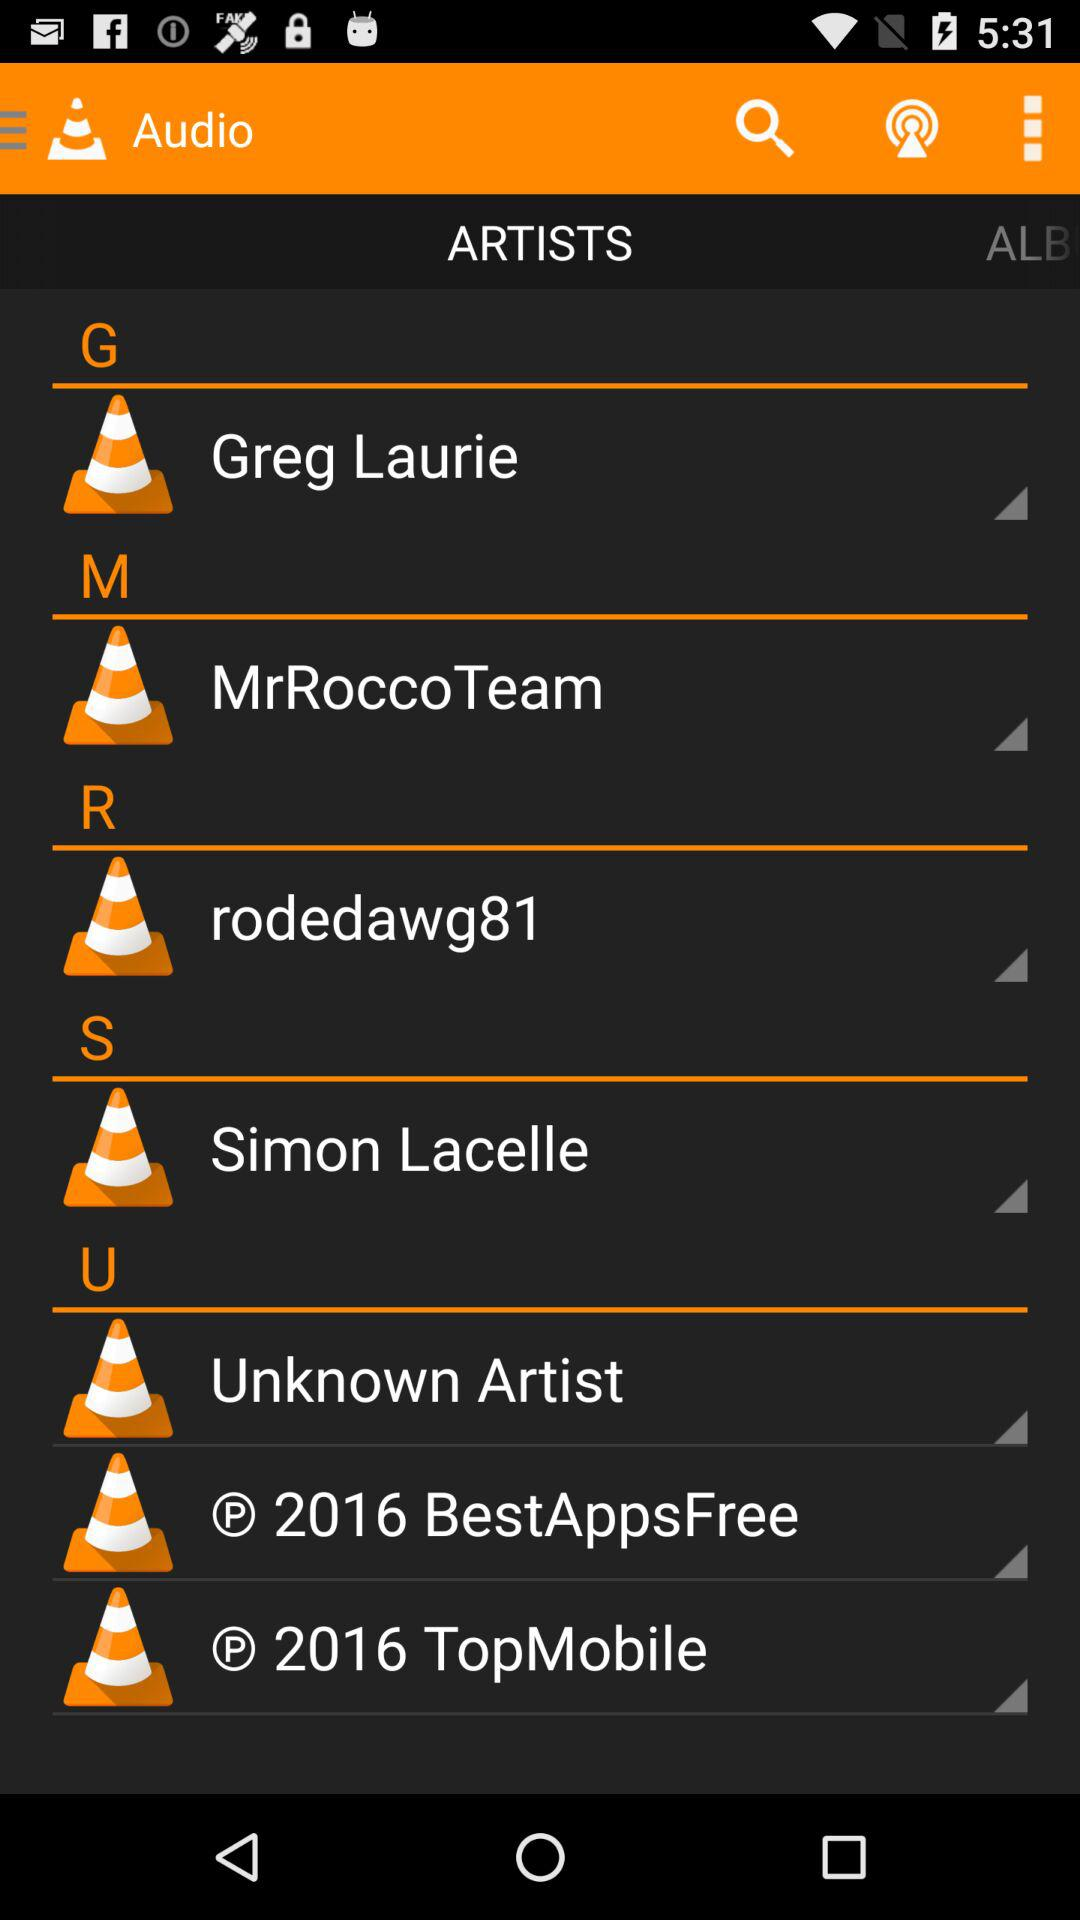What artist's name starts with G? The artist's name is "Greg Laurie". 